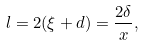Convert formula to latex. <formula><loc_0><loc_0><loc_500><loc_500>l = 2 ( \xi + d ) = \frac { 2 \delta } { x } ,</formula> 